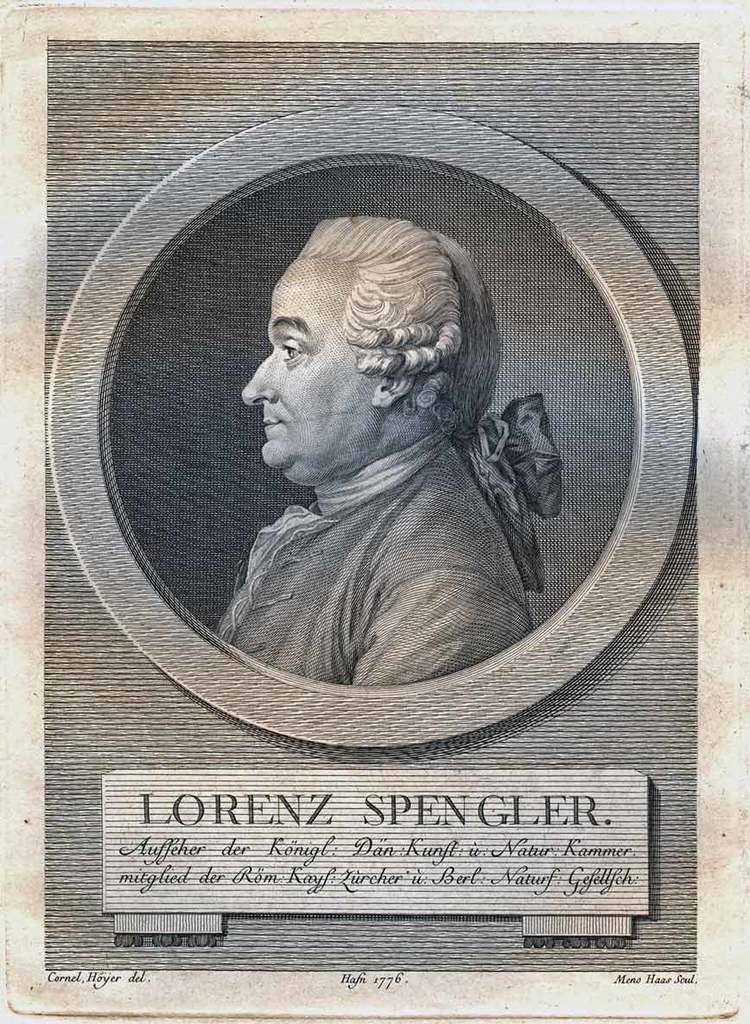What is present in the image that features an image of a person? There is a poster in the image that contains an image of a person. What else can be found on the poster besides the image? There is text written on the poster. What type of fowl can be seen perched on the text of the poster? There is no fowl present on the poster in the image. How many bells are attached to the image of the person on the poster? There are no bells attached to the image of the person on the poster. 